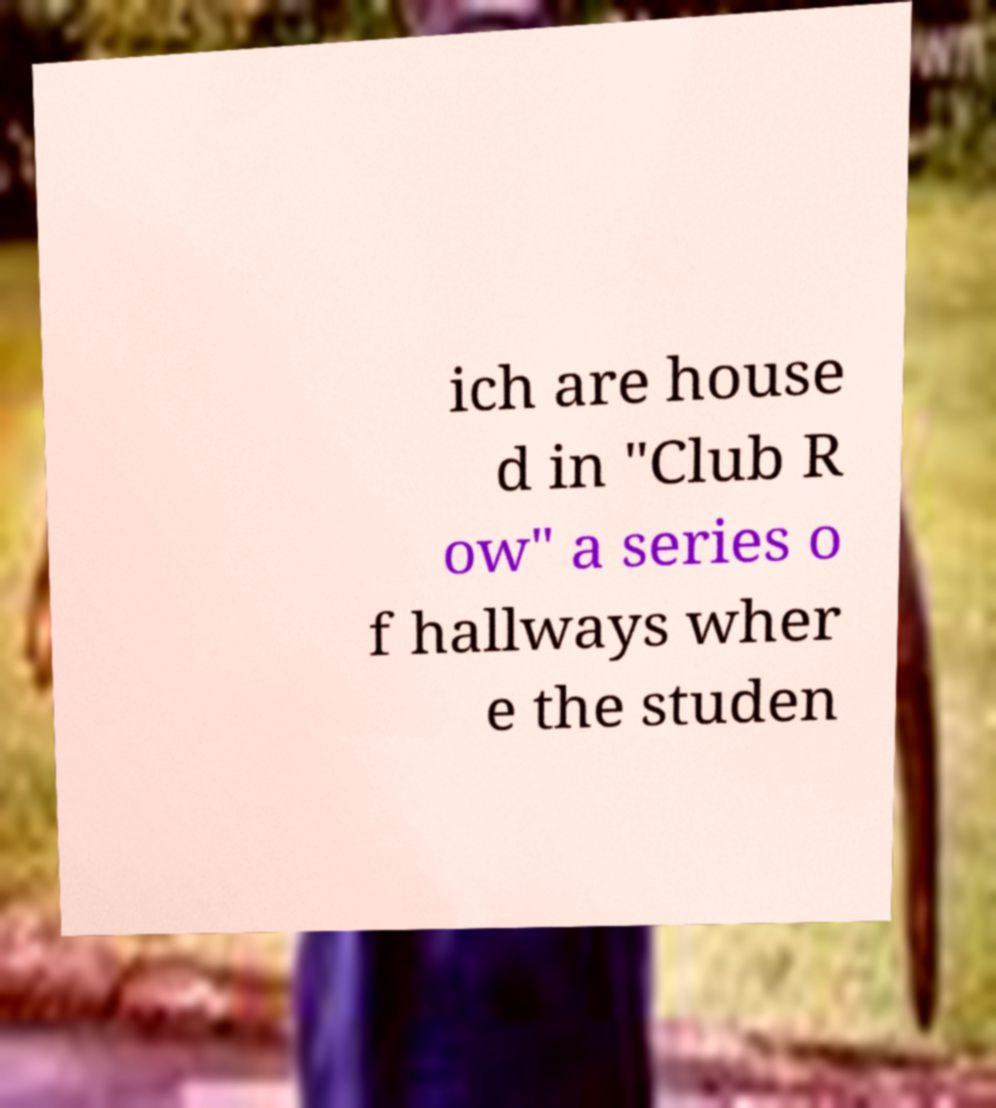What messages or text are displayed in this image? I need them in a readable, typed format. ich are house d in "Club R ow" a series o f hallways wher e the studen 